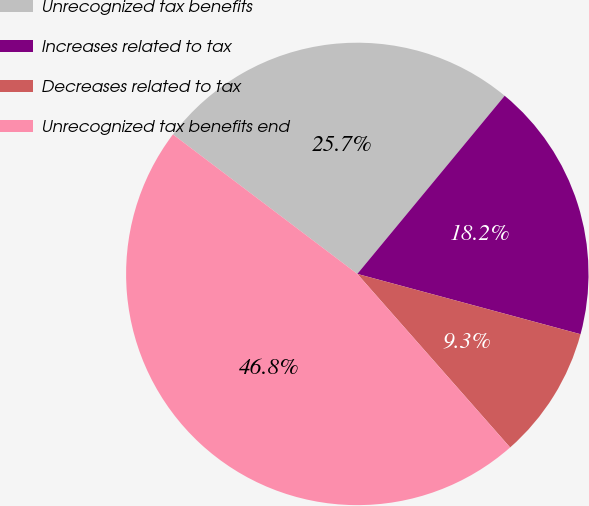<chart> <loc_0><loc_0><loc_500><loc_500><pie_chart><fcel>Unrecognized tax benefits<fcel>Increases related to tax<fcel>Decreases related to tax<fcel>Unrecognized tax benefits end<nl><fcel>25.69%<fcel>18.2%<fcel>9.31%<fcel>46.8%<nl></chart> 